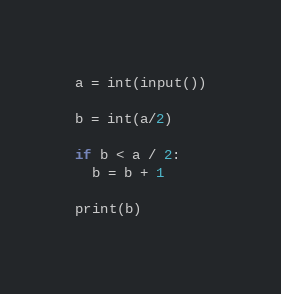<code> <loc_0><loc_0><loc_500><loc_500><_Python_>a = int(input())

b = int(a/2)

if b < a / 2:
  b = b + 1
 
print(b)</code> 